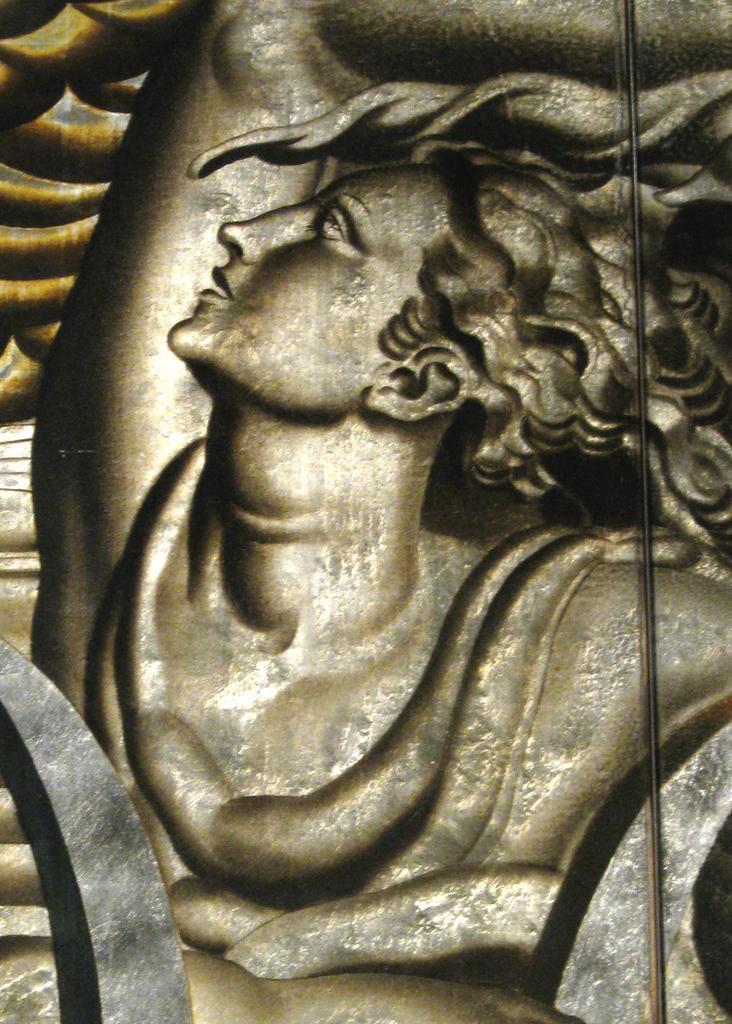Please provide a concise description of this image. In this image there is a sculpture. 